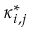Convert formula to latex. <formula><loc_0><loc_0><loc_500><loc_500>\kappa _ { i , j } ^ { * }</formula> 